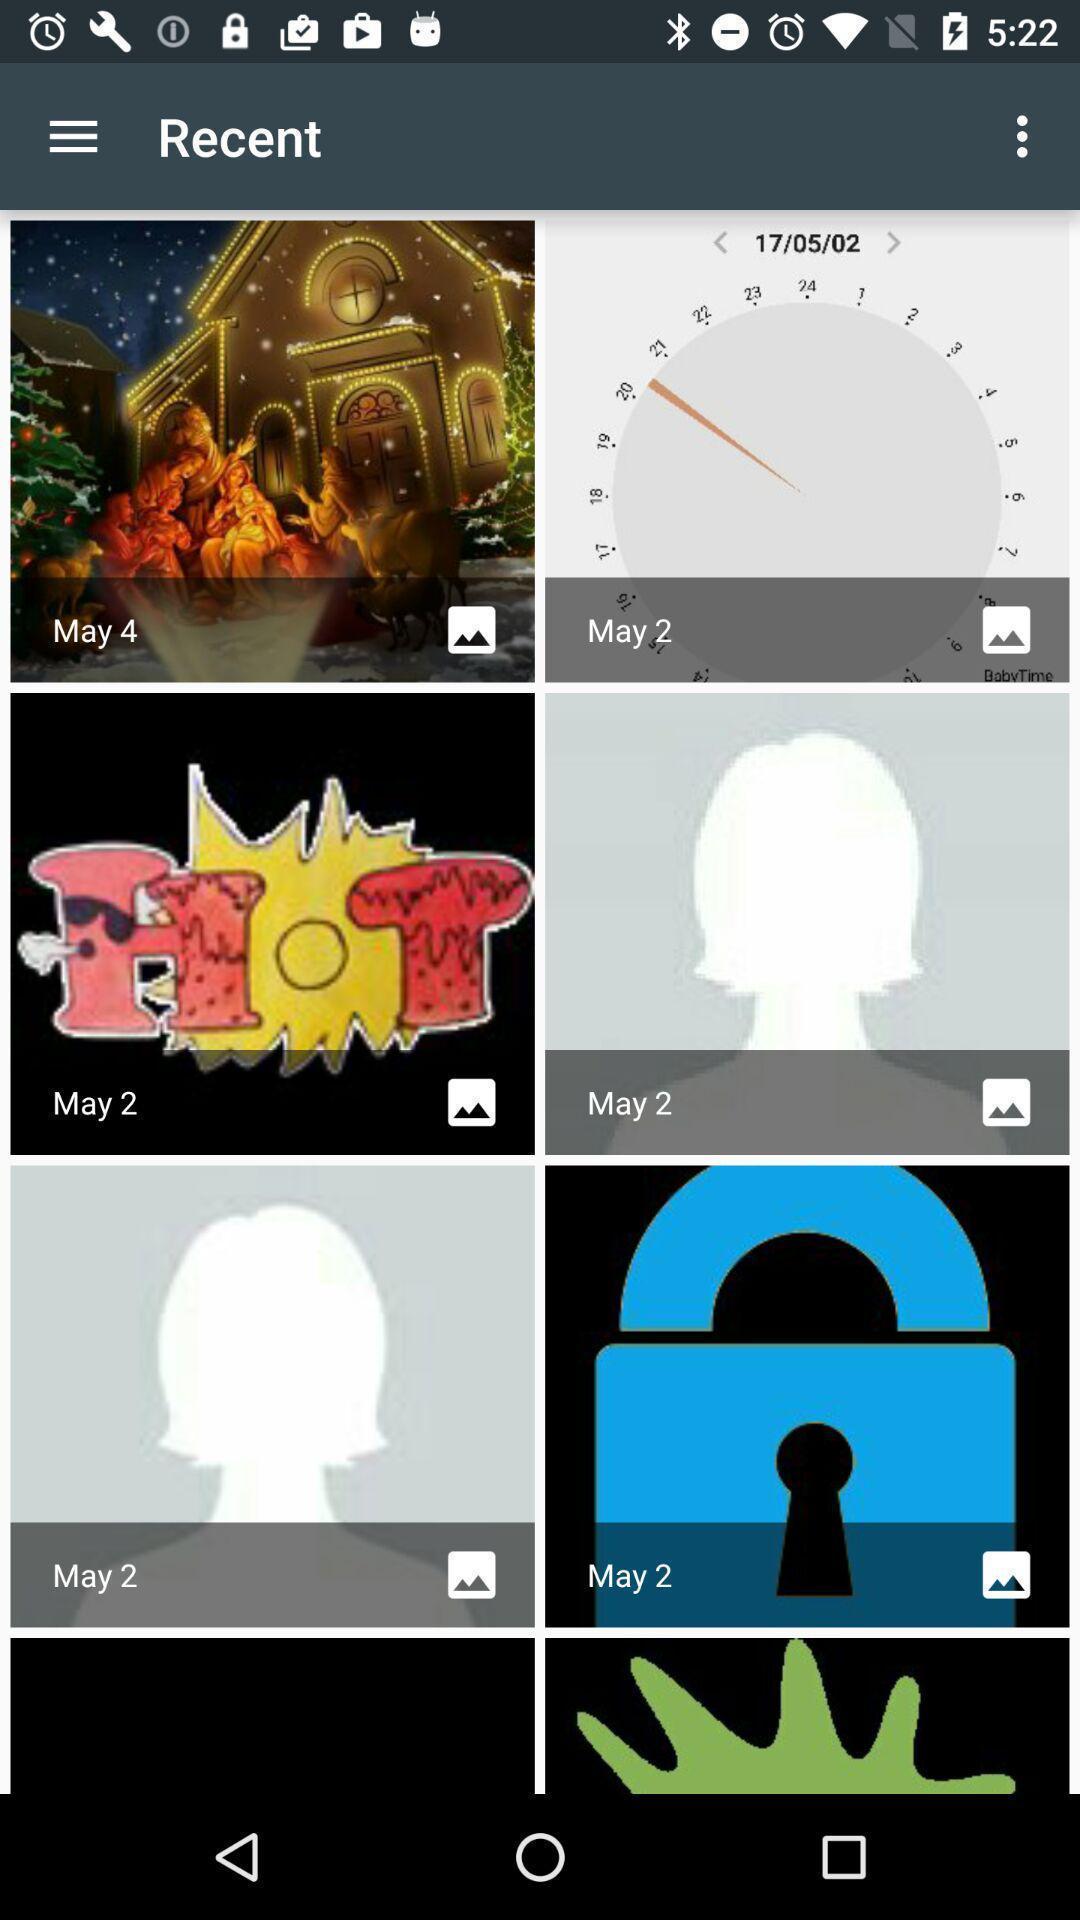Please provide a description for this image. Recent images in the gallery. 